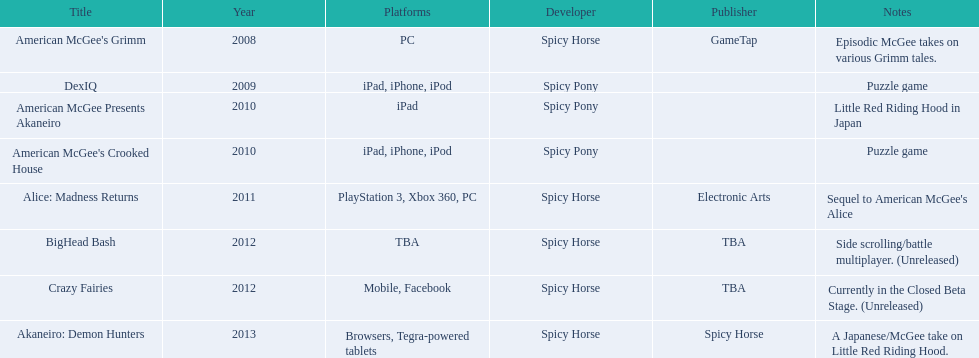What was the number of platforms that supported american mcgee's grimm? 1. 